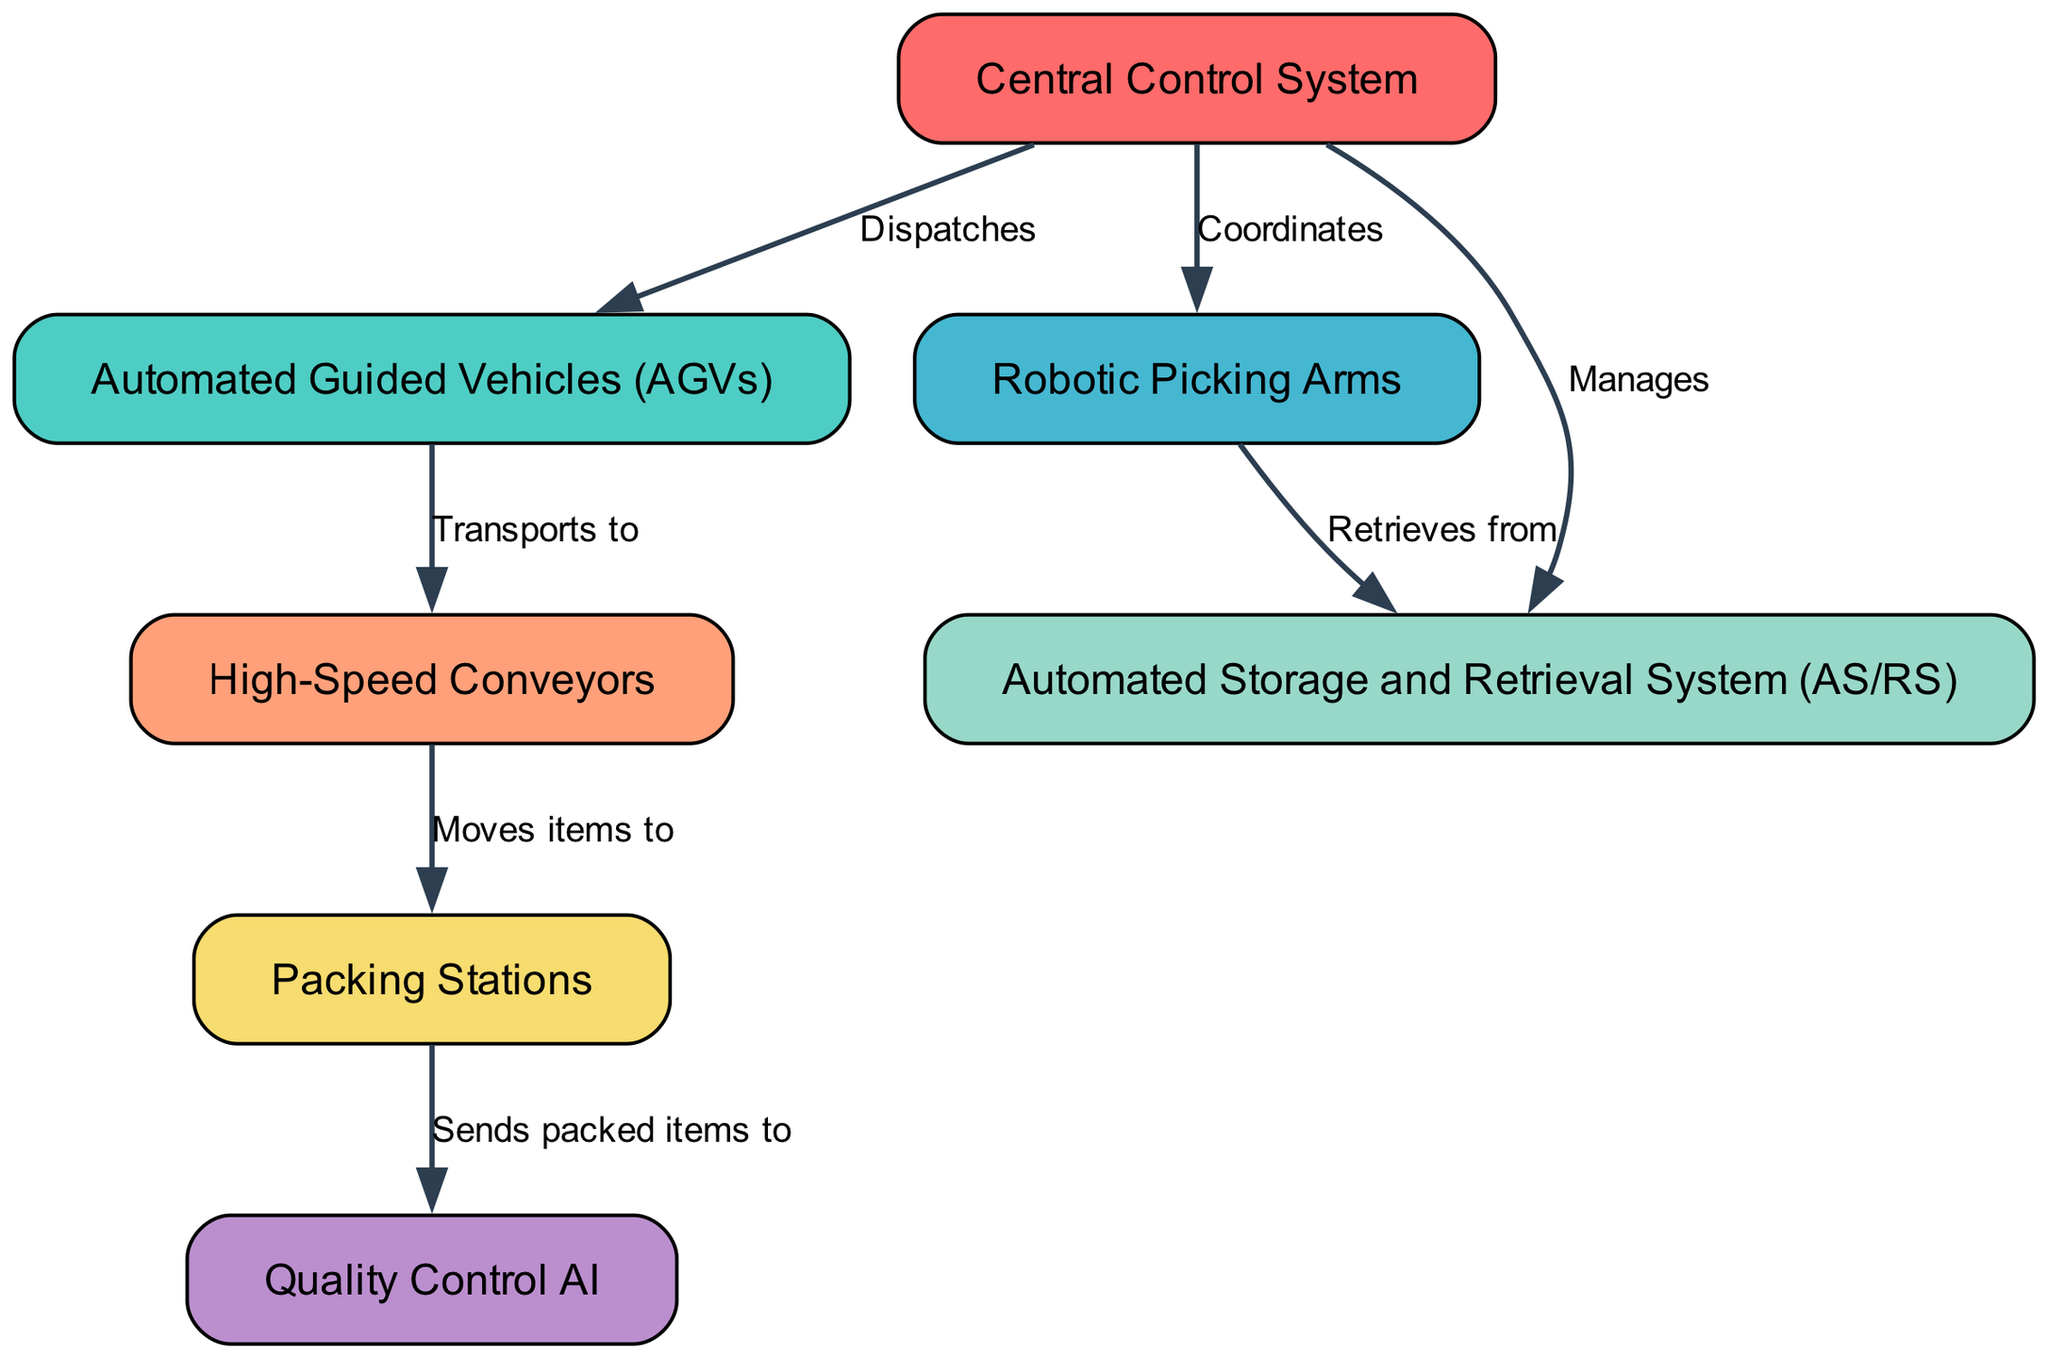What is the total number of nodes in the diagram? The diagram contains seven nodes representing different components of the automated warehouse system. By counting the nodes listed, we see seven distinct elements such as the Central Control System, Automated Guided Vehicles, and others.
Answer: 7 Which node is responsible for managing the Automated Storage and Retrieval System? The Central Control System manages the Automated Storage and Retrieval System according to the directed edge shown in the diagram, indicating the flow and management responsibility.
Answer: Central Control System How many edges are there in the diagram? To find the total number of edges, we can count the connections between the nodes. The diagram contains six edges that connect the various components in the automated warehouse system, illustrating the relationships and actions.
Answer: 6 What component sends packed items to Quality Control AI? The Packing Stations send packed items to the Quality Control AI, as shown by the directed edge in the diagram that connects these two nodes with the labeled action.
Answer: Packing Stations Which component retrieves items from the Automated Storage and Retrieval System? The Robotic Picking Arms retrieve items from the Automated Storage and Retrieval System, evidenced by the directed edge that indicates the flow of action between these two nodes.
Answer: Robotic Picking Arms What is the action taken by the Automated Guided Vehicles? The Automated Guided Vehicles transport items to the High-Speed Conveyors, as indicated by the edge connecting these two nodes with the labeled action that describes what the AGVs do.
Answer: Transports to How does the Central Control System interact with the Robotic Picking Arms? The Central Control System coordinates with the Robotic Picking Arms, as represented by the directed edge in the diagram that shows this interaction explicitly.
Answer: Coordinates Which component is directly linked to Packing Stations? The High-Speed Conveyors are directly linked to the Packing Stations, as indicated by the edge that connects these two components in the diagram and shows the flow of items to the packing area.
Answer: High-Speed Conveyors What node do the Automated Guided Vehicles dispatch items to? The Automated Guided Vehicles are dispatched by the Central Control System, demonstrating their role in the transportation process within the automated warehouse system as noted in the directed edge.
Answer: Automated Guided Vehicles 